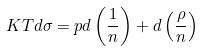Convert formula to latex. <formula><loc_0><loc_0><loc_500><loc_500>K T d \sigma = p d \left ( \frac { 1 } { n } \right ) + d \left ( \frac { \rho } { n } \right )</formula> 